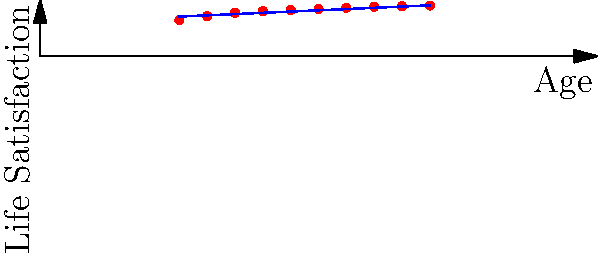Based on the scatter plot showing the relationship between age and life satisfaction scores for child-free individuals, what can be inferred about the trend of life satisfaction as age increases? To answer this question, we need to analyze the scatter plot and the trend line:

1. Observe the data points:
   - The red dots represent individual data points for child-free people at different ages.
   - The x-axis represents age, ranging from 25 to 70 years.
   - The y-axis represents life satisfaction scores, ranging from 0 to 10.

2. Analyze the distribution of points:
   - As we move from left to right (increasing age), we can see that the points tend to move upward.
   - This indicates a general increase in life satisfaction scores as age increases.

3. Examine the trend line:
   - The blue line represents the overall trend of the data.
   - The line has a positive slope, confirming the upward trend observed in the scatter points.

4. Interpret the trend:
   - The positive correlation between age and life satisfaction suggests that, on average, child-free individuals tend to report higher life satisfaction as they get older.
   - The increase appears to be gradual but consistent across the age range shown.

5. Consider the limitations:
   - This is a general trend and may not apply to every individual.
   - Other factors not shown in this plot could also influence life satisfaction.

Based on this analysis, we can conclude that the data suggests a positive correlation between age and life satisfaction for child-free individuals, with satisfaction tending to increase as age increases.
Answer: Positive correlation: life satisfaction tends to increase with age for child-free individuals. 